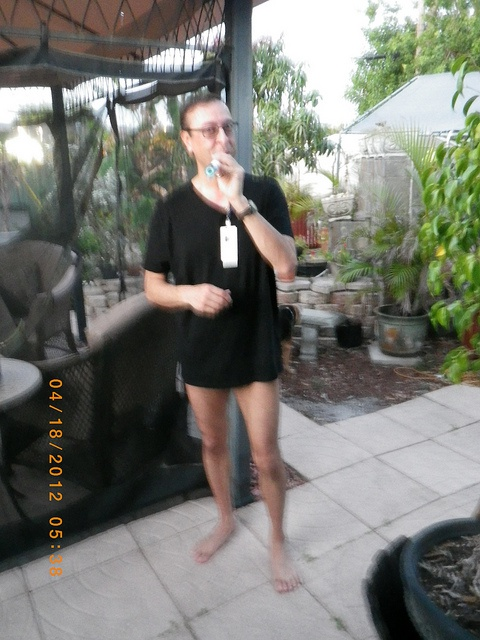Describe the objects in this image and their specific colors. I can see people in brown, black, darkgray, and gray tones, chair in brown, black, gray, darkgray, and orange tones, potted plant in brown, darkgreen, and olive tones, potted plant in brown, black, gray, purple, and darkgray tones, and potted plant in brown, gray, darkgray, darkgreen, and black tones in this image. 